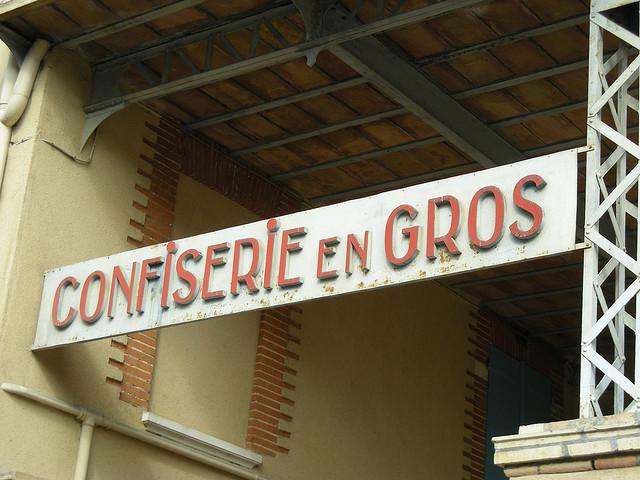What color are the letters on the sign?
Be succinct. Red. Are those steel beams on the ceiling?
Quick response, please. Yes. Is this a store name?
Be succinct. Yes. 